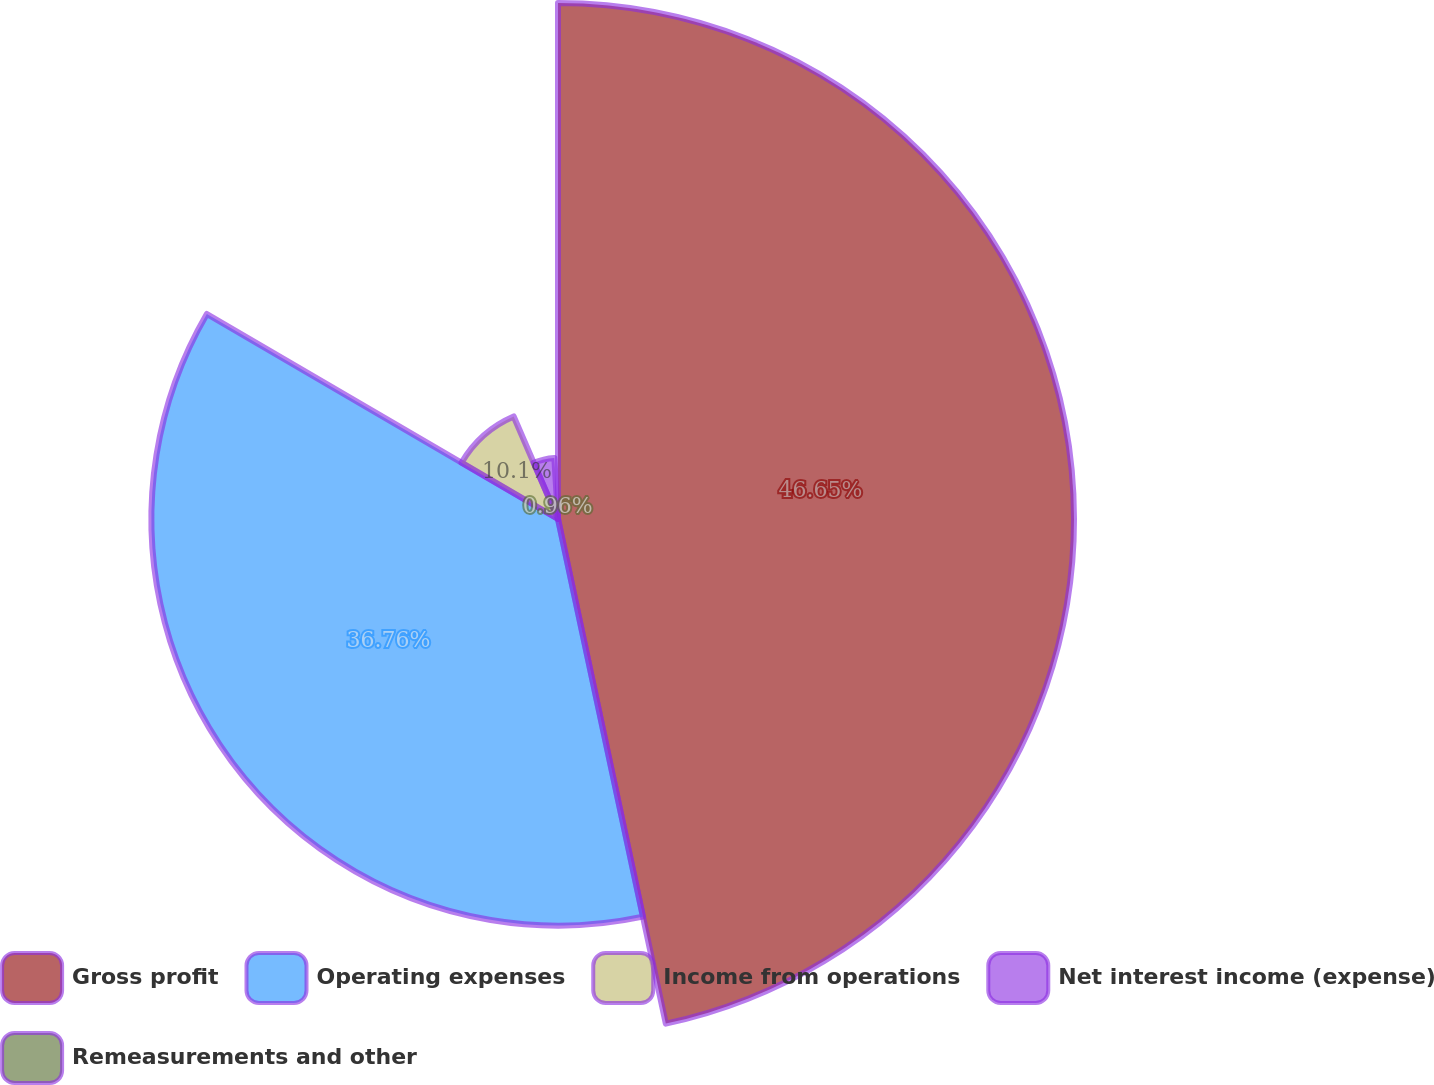Convert chart. <chart><loc_0><loc_0><loc_500><loc_500><pie_chart><fcel>Gross profit<fcel>Operating expenses<fcel>Income from operations<fcel>Net interest income (expense)<fcel>Remeasurements and other<nl><fcel>46.65%<fcel>36.76%<fcel>10.1%<fcel>5.53%<fcel>0.96%<nl></chart> 